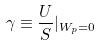<formula> <loc_0><loc_0><loc_500><loc_500>\gamma \equiv \frac { U } { S } | _ { W _ { p } = 0 }</formula> 